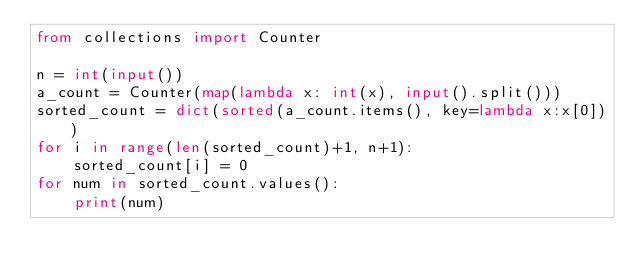Convert code to text. <code><loc_0><loc_0><loc_500><loc_500><_Python_>from collections import Counter

n = int(input())
a_count = Counter(map(lambda x: int(x), input().split()))
sorted_count = dict(sorted(a_count.items(), key=lambda x:x[0]))
for i in range(len(sorted_count)+1, n+1):
    sorted_count[i] = 0
for num in sorted_count.values():
    print(num)</code> 